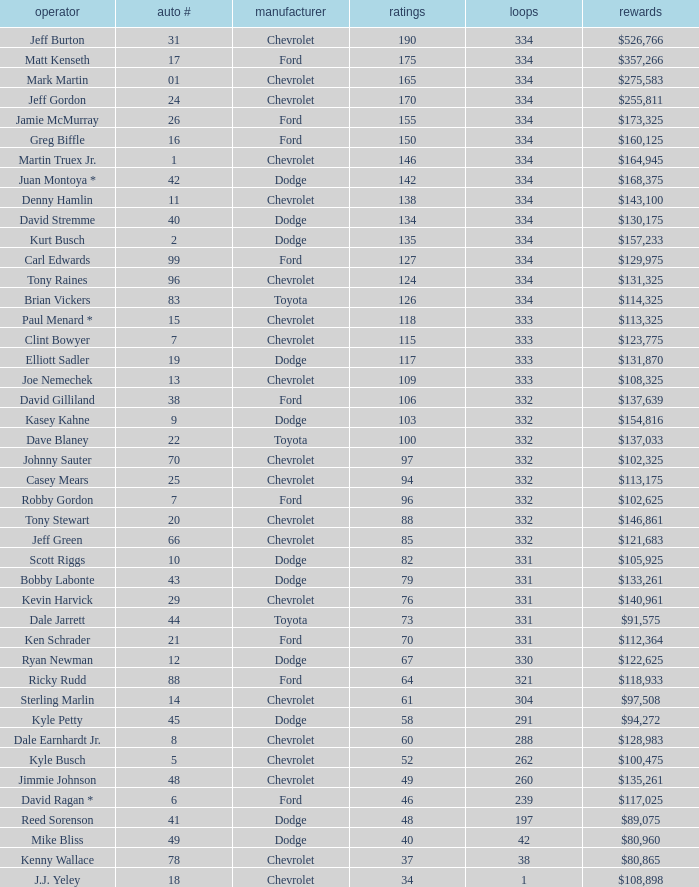How many total laps did the Chevrolet that won $97,508 make? 1.0. 